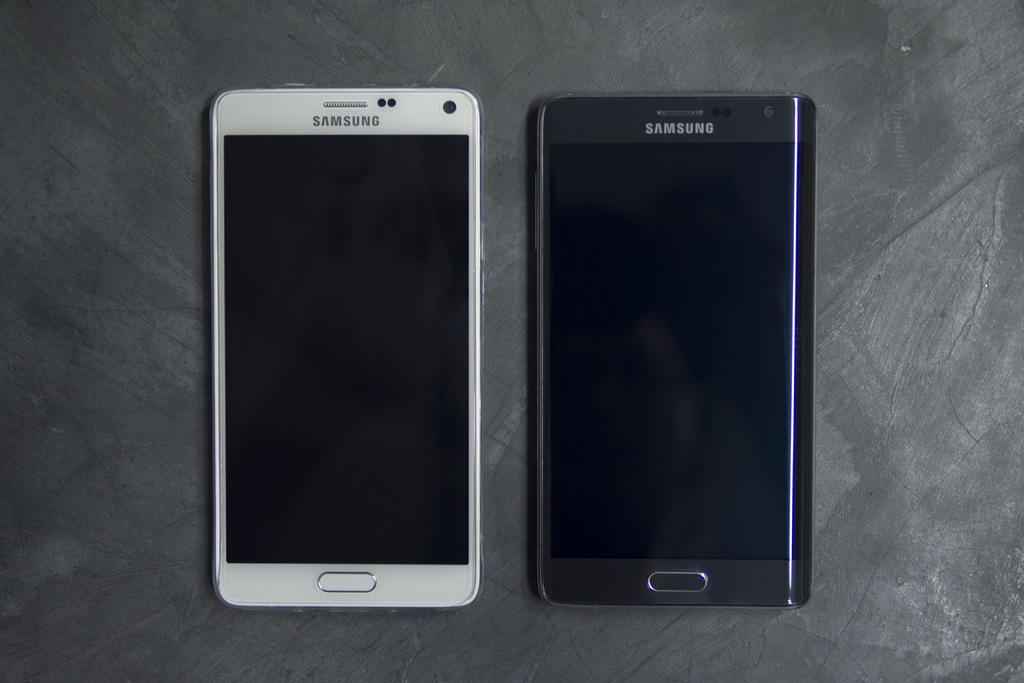What kind of phones are these?
Provide a succinct answer. Samsung. 